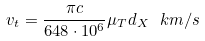Convert formula to latex. <formula><loc_0><loc_0><loc_500><loc_500>v _ { t } = \frac { \pi c } { 6 4 8 \cdot 1 0 ^ { 6 } } \mu _ { T } d _ { X } \ k m / s</formula> 